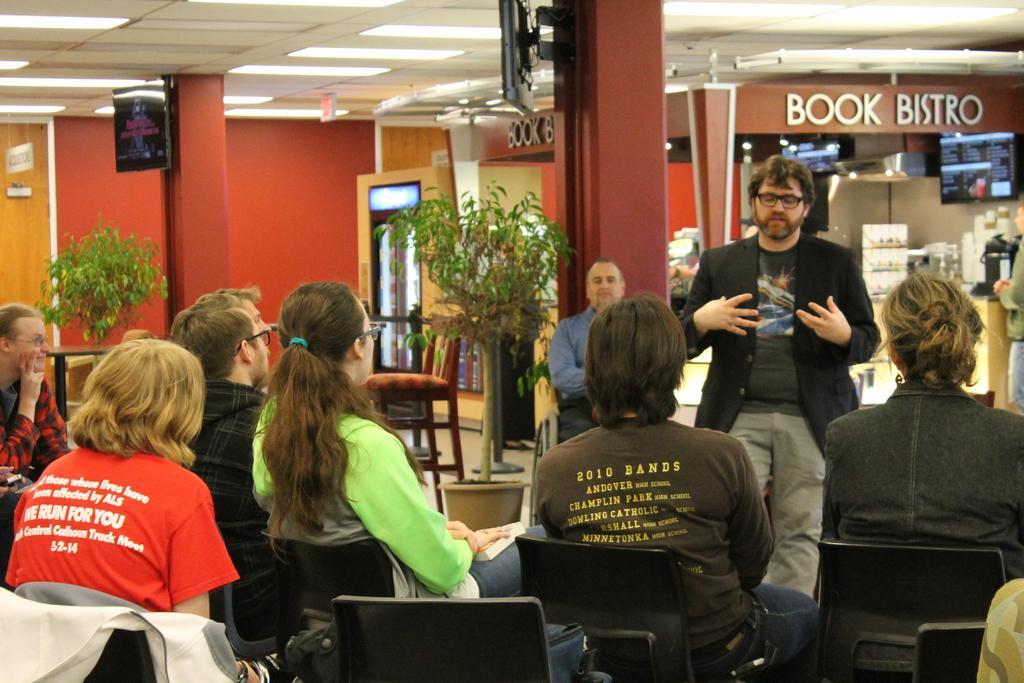In one or two sentences, can you explain what this image depicts? In this picture I can see few people are sitting on the chairs and watching, among them one person is standing and talking, side there are some potted plants placed and also I can see few objects are around. 